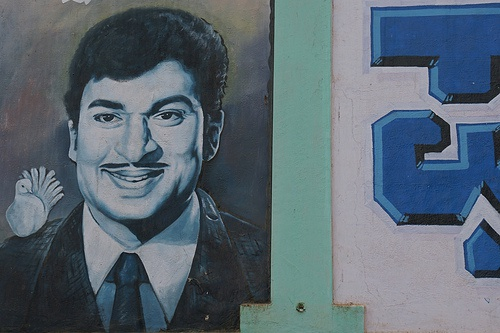Describe the objects in this image and their specific colors. I can see people in gray, black, darkgray, and blue tones, bird in gray and darkgray tones, and tie in gray, black, darkblue, blue, and darkgray tones in this image. 